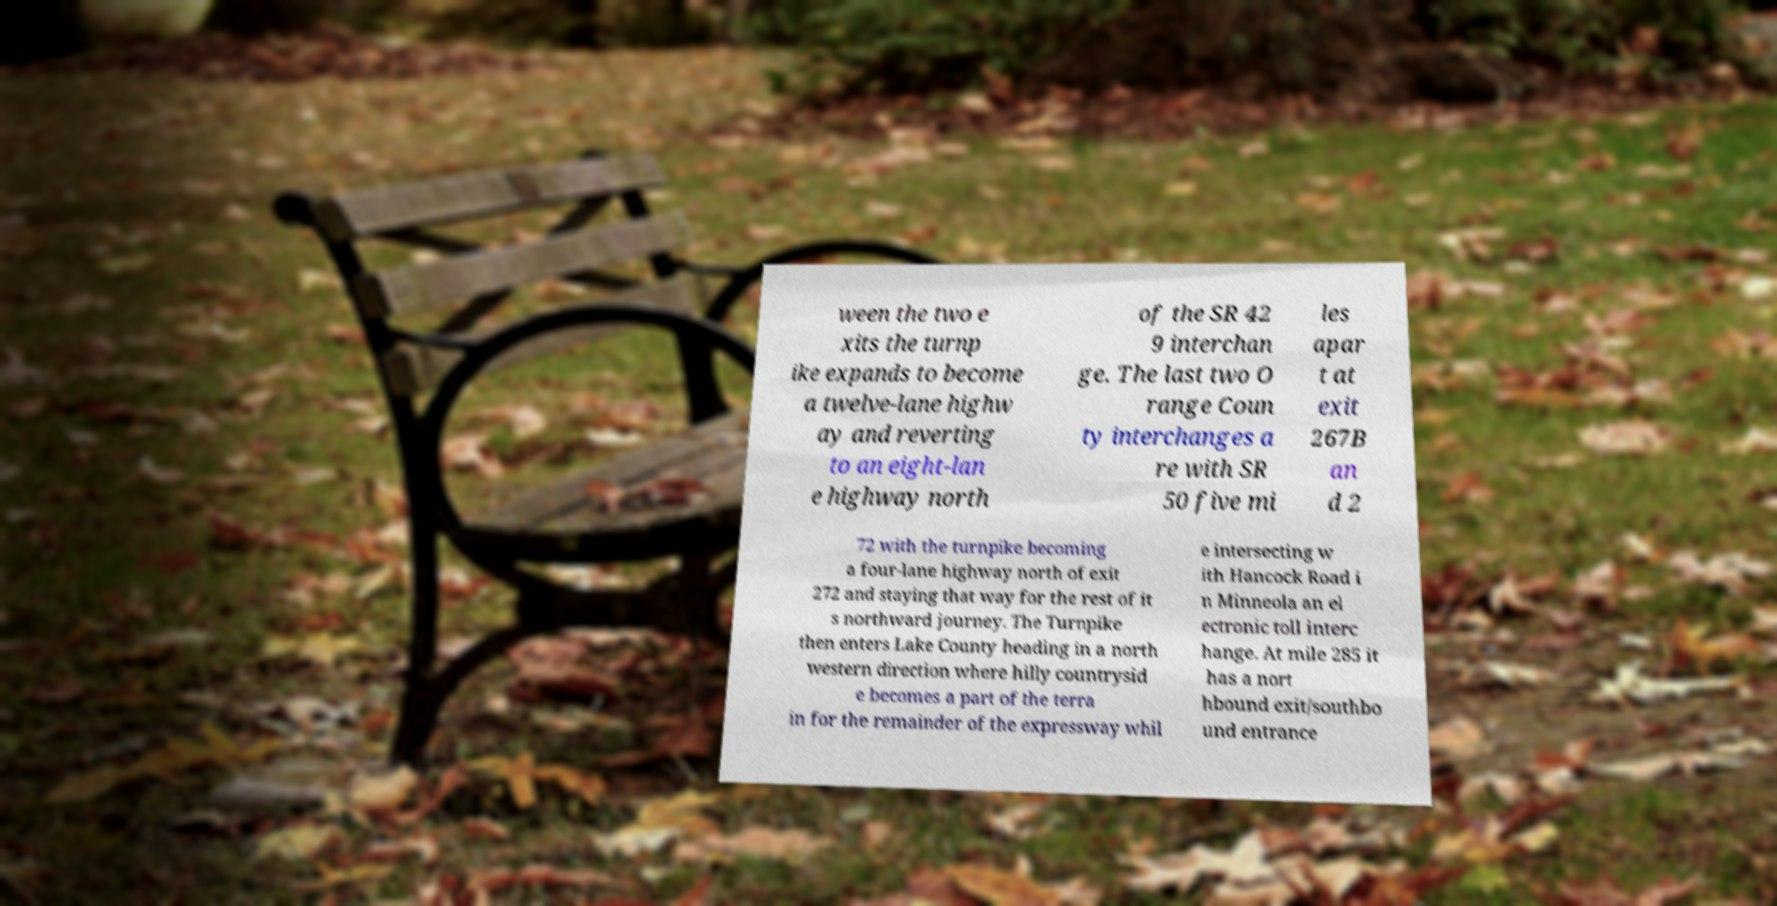Could you assist in decoding the text presented in this image and type it out clearly? ween the two e xits the turnp ike expands to become a twelve-lane highw ay and reverting to an eight-lan e highway north of the SR 42 9 interchan ge. The last two O range Coun ty interchanges a re with SR 50 five mi les apar t at exit 267B an d 2 72 with the turnpike becoming a four-lane highway north of exit 272 and staying that way for the rest of it s northward journey. The Turnpike then enters Lake County heading in a north western direction where hilly countrysid e becomes a part of the terra in for the remainder of the expressway whil e intersecting w ith Hancock Road i n Minneola an el ectronic toll interc hange. At mile 285 it has a nort hbound exit/southbo und entrance 